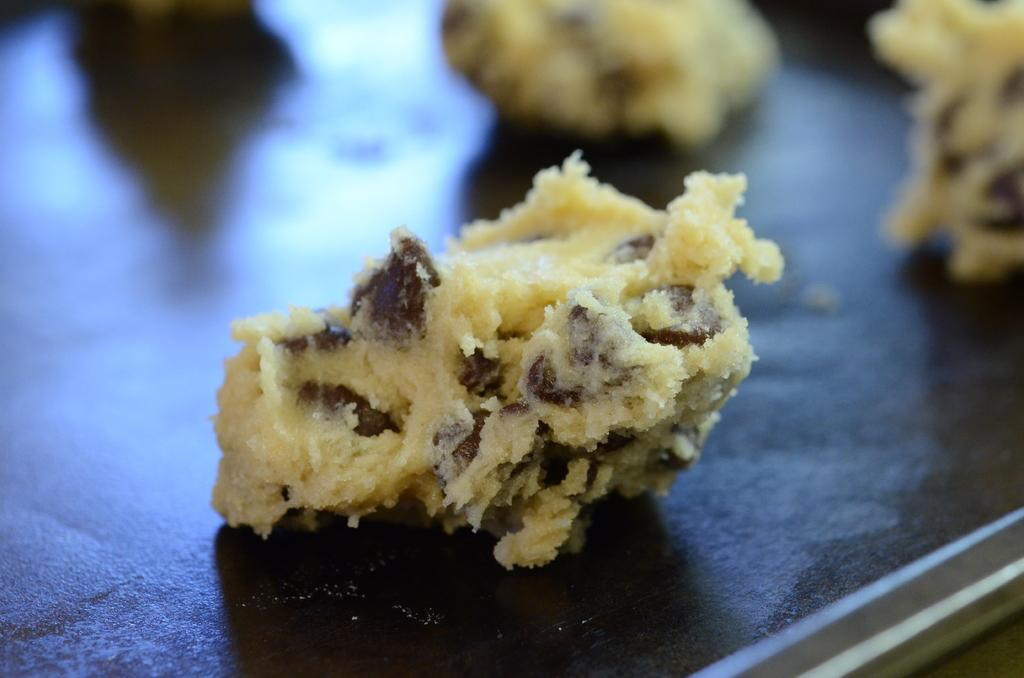What type of food can be seen in the image? The specific type of food cannot be determined from the provided facts. What is the color of the surface on which the food is placed? The surface is black. What is the moon doing in the image? The moon is not present in the image; it is a celestial body in space. What rule is being enforced in the image? There is no indication of any rules being enforced in the image. Where is the bucket located in the image? There is no bucket present in the image. 